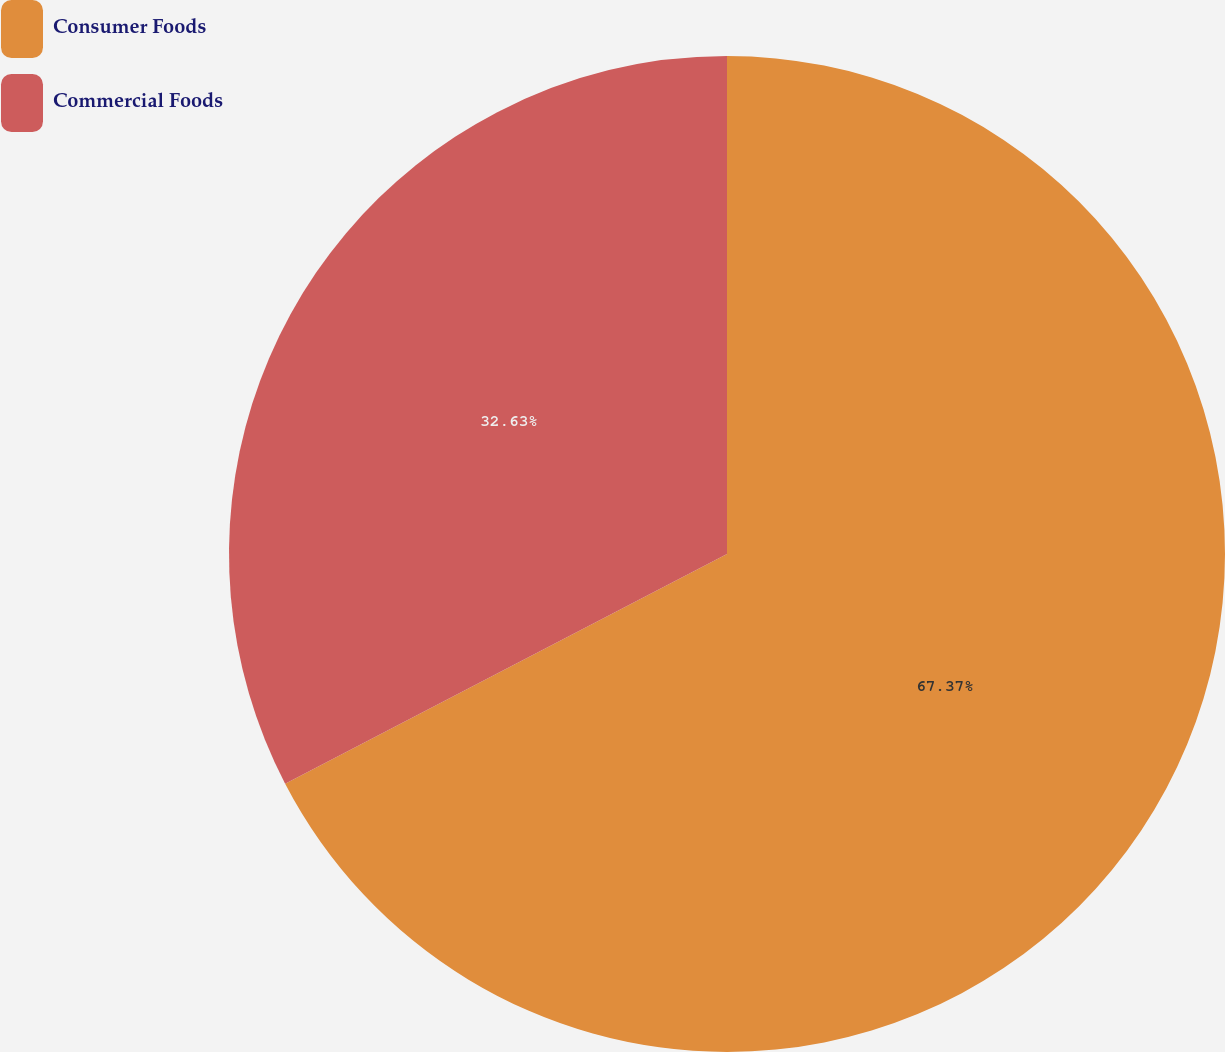<chart> <loc_0><loc_0><loc_500><loc_500><pie_chart><fcel>Consumer Foods<fcel>Commercial Foods<nl><fcel>67.37%<fcel>32.63%<nl></chart> 